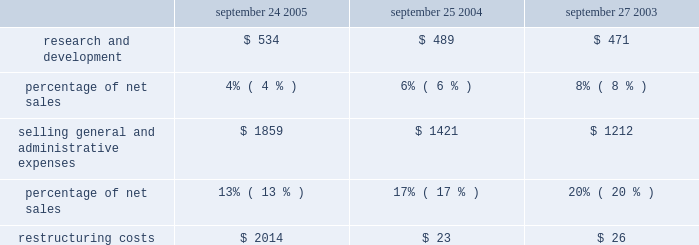The company orders components for its products and builds inventory in advance of product shipments .
Because the company 2019s markets are volatile and subject to rapid technology and price changes , there is a risk the company will forecast incorrectly and produce or order from third-parties excess or insufficient inventories of particular products or components .
The company 2019s operating results and financial condition in the past have been and may in the future be materially adversely affected by the company 2019s ability to manage its inventory levels and outstanding purchase commitments and to respond to short-term shifts in customer demand patterns .
Gross margin declined in 2004 to 27.3% ( 27.3 % ) of net sales from 27.5% ( 27.5 % ) of net sales in 2003 .
The company 2019s gross margin during 2004 declined due to an increase in mix towards lower margin ipod and ibook sales , pricing actions on certain power macintosh g5 models that were transitioned during the beginning of 2004 , higher warranty costs on certain portable macintosh products , and higher freight and duty costs during 2004 .
These unfavorable factors were partially offset by an increase in direct sales and a 39% ( 39 % ) year-over-year increase in higher margin software sales .
Operating expenses operating expenses for each of the last three fiscal years are as follows ( in millions , except for percentages ) : september 24 , september 25 , september 27 , 2005 2004 2003 .
Research and development ( r&d ) the company recognizes that focused investments in r&d are critical to its future growth and competitive position in the marketplace and are directly related to timely development of new and enhanced products that are central to the company 2019s core business strategy .
The company has historically relied upon innovation to remain competitive .
R&d expense amounted to approximately 4% ( 4 % ) of total net sales during 2005 down from 6% ( 6 % ) and 8% ( 8 % ) of total net sales in 2004 and 2003 , respectively .
This decrease is due to the significant increase of 68% ( 68 % ) in total net sales of the company for 2005 .
Although r&d expense decreased as a percentage of total net sales in 2005 , actual expense for r&d in 2005 increased $ 45 million or 9% ( 9 % ) from 2004 , which follows an $ 18 million or 4% ( 4 % ) increase in 2004 compared to 2003 .
The overall increase in r&d expense relates primarily to increased headcount and support for new product development activities and the impact of employee salary increases in 2005 .
R&d expense does not include capitalized software development costs of approximately $ 29.7 million related to the development of mac os x tiger during 2005 ; $ 4.5 million related to the development of mac os x tiger and $ 2.3 million related to the development of filemaker pro 7 in 2004 ; and $ 14.7 million related to the development of mac os x panther in 2003 .
Further information related to the company 2019s capitalization of software development costs may be found in part ii , item 8 of this form 10-k at note 1 of notes to consolidated financial statements .
Selling , general , and administrative expense ( sg&a ) expenditures for sg&a increased $ 438 million or 31% ( 31 % ) during 2005 compared to 2004 .
These increases are due primarily to the company 2019s continued expansion of its retail segment in both domestic and international markets , a current year increase in discretionary spending on marketing and advertising , and higher direct and channel selling expenses resulting from the increase in net sales and employee salary .
Research and development were what percent of\\nselling general and administrative expenses in 2005? 
Computations: (534 / 1859)
Answer: 0.28725. 